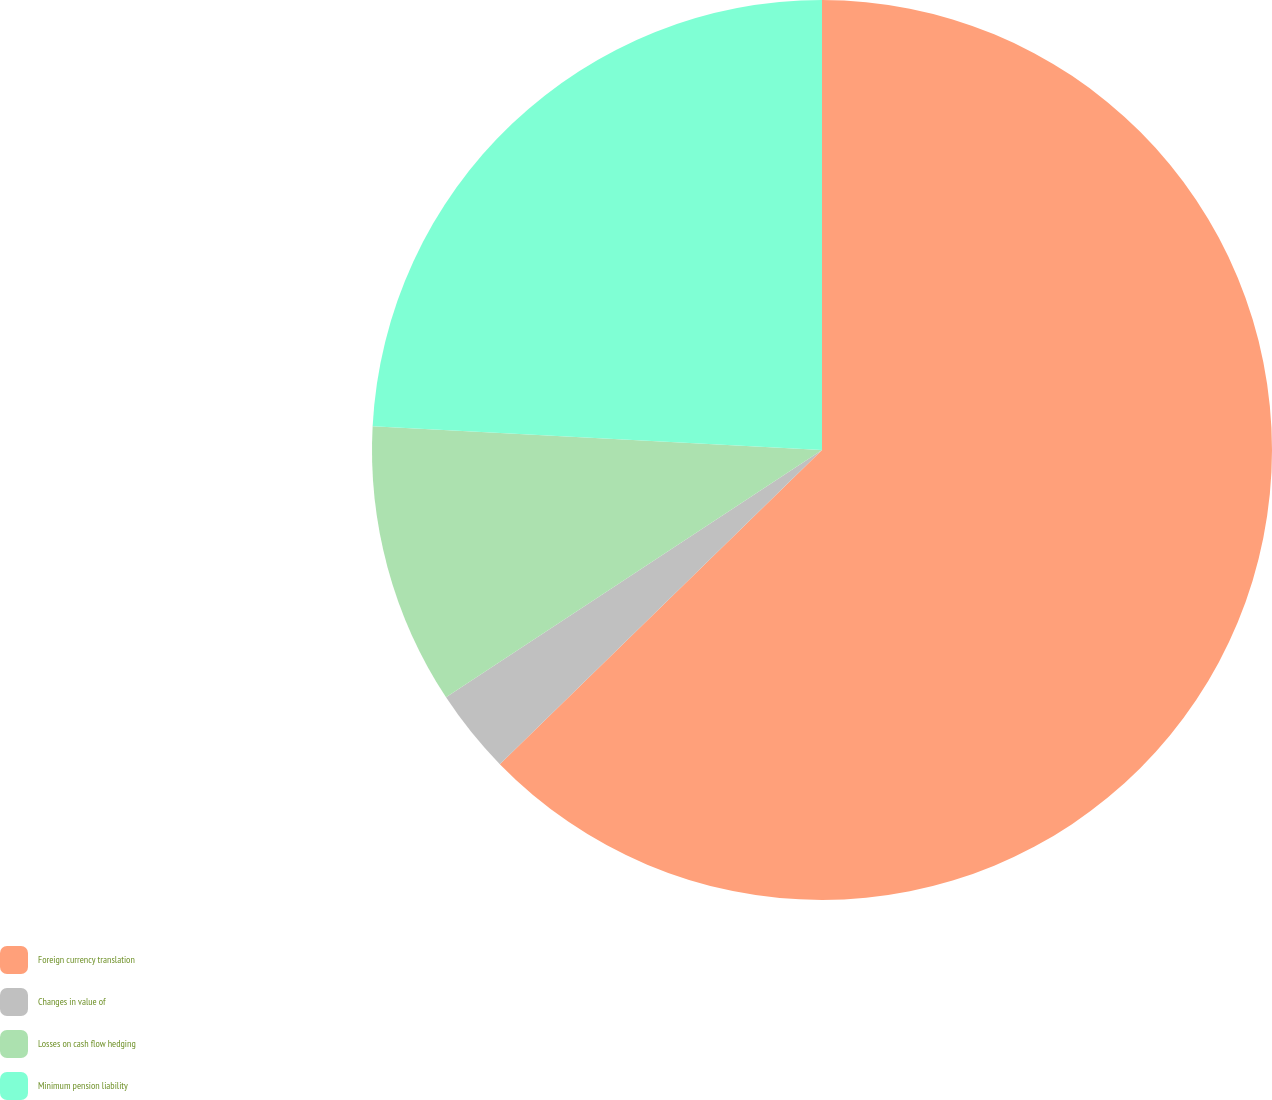Convert chart. <chart><loc_0><loc_0><loc_500><loc_500><pie_chart><fcel>Foreign currency translation<fcel>Changes in value of<fcel>Losses on cash flow hedging<fcel>Minimum pension liability<nl><fcel>62.7%<fcel>3.04%<fcel>10.1%<fcel>24.16%<nl></chart> 